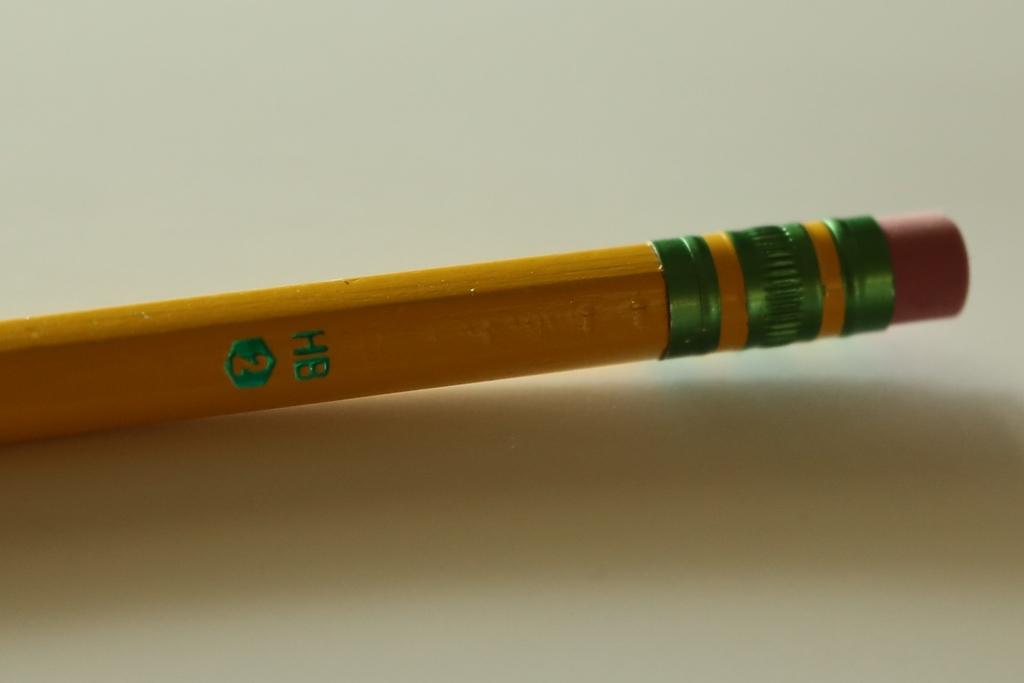What number is the pencil?
Ensure brevity in your answer.  2. What initials are written on this pencil?
Keep it short and to the point. Hb. 